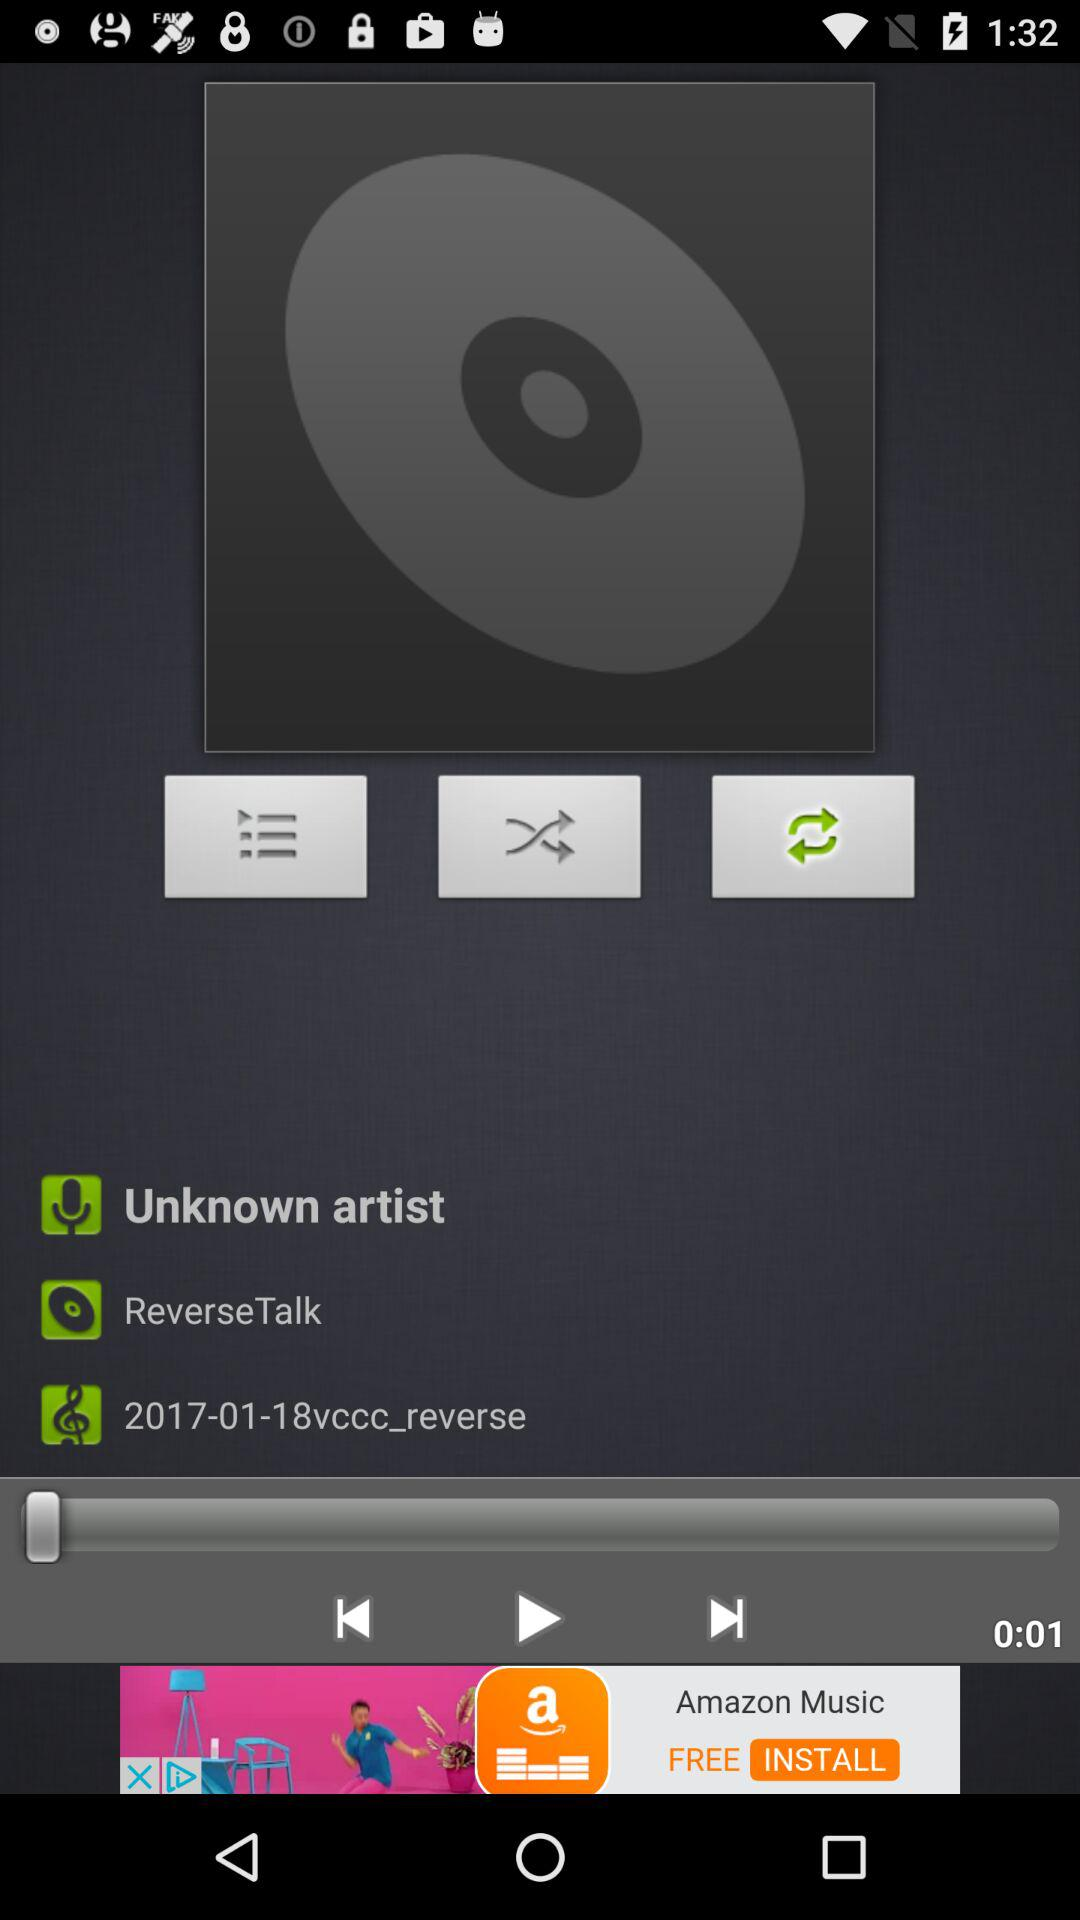How much time has elapsed since the beginning of the track?
Answer the question using a single word or phrase. 0:01 